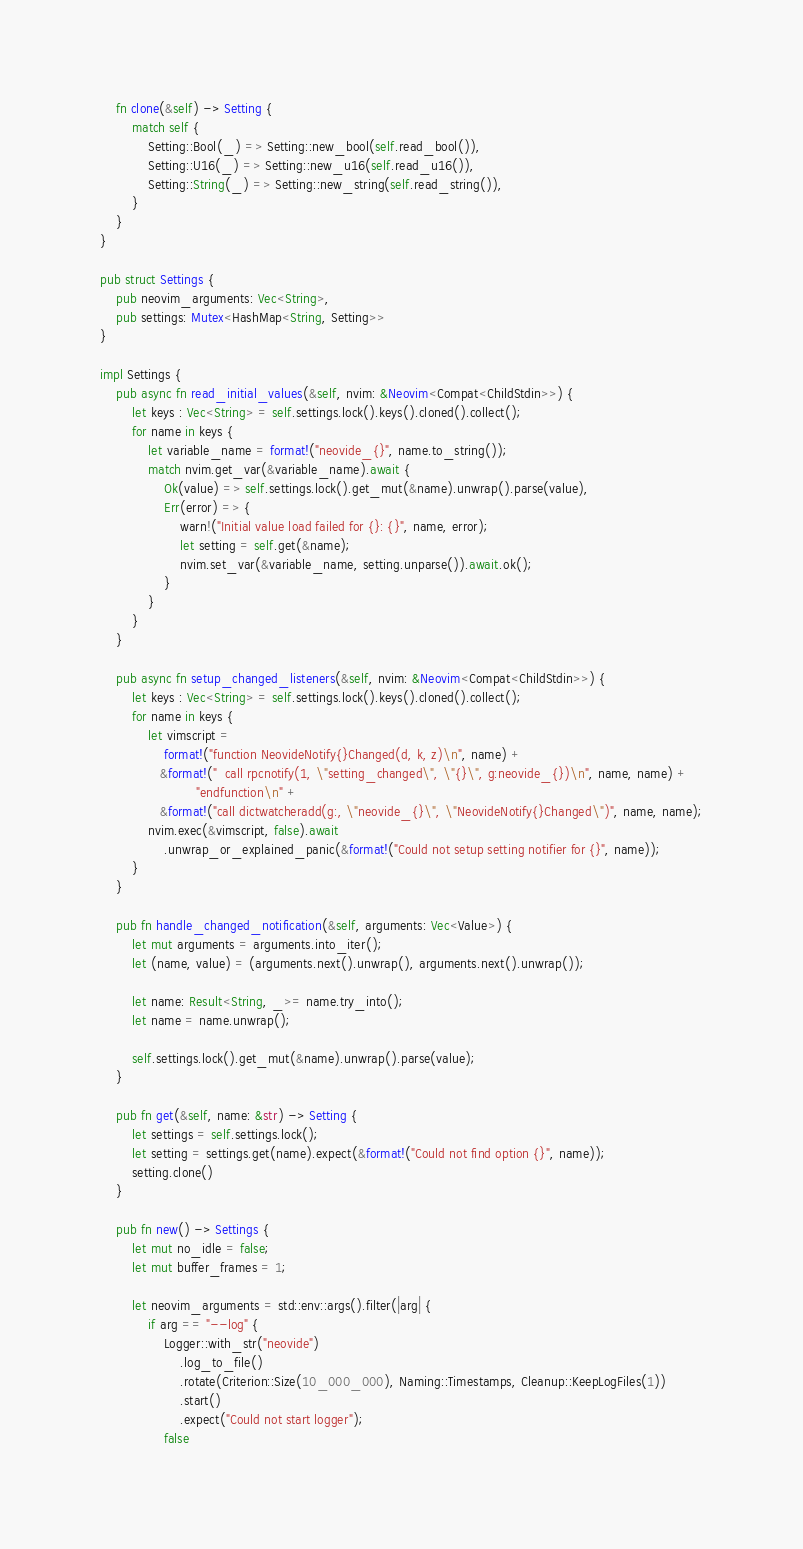<code> <loc_0><loc_0><loc_500><loc_500><_Rust_>
    fn clone(&self) -> Setting {
        match self {
            Setting::Bool(_) => Setting::new_bool(self.read_bool()),
            Setting::U16(_) => Setting::new_u16(self.read_u16()),
            Setting::String(_) => Setting::new_string(self.read_string()),
        }
    }
}

pub struct Settings {
    pub neovim_arguments: Vec<String>,
    pub settings: Mutex<HashMap<String, Setting>>
}

impl Settings {
    pub async fn read_initial_values(&self, nvim: &Neovim<Compat<ChildStdin>>) {
        let keys : Vec<String> = self.settings.lock().keys().cloned().collect();
        for name in keys {
            let variable_name = format!("neovide_{}", name.to_string());
            match nvim.get_var(&variable_name).await {
                Ok(value) => self.settings.lock().get_mut(&name).unwrap().parse(value),
                Err(error) => {
                    warn!("Initial value load failed for {}: {}", name, error);
                    let setting = self.get(&name);
                    nvim.set_var(&variable_name, setting.unparse()).await.ok();
                }
            }
        }
    }

    pub async fn setup_changed_listeners(&self, nvim: &Neovim<Compat<ChildStdin>>) {
        let keys : Vec<String> = self.settings.lock().keys().cloned().collect();
        for name in keys {
            let vimscript = 
                format!("function NeovideNotify{}Changed(d, k, z)\n", name) +
               &format!("  call rpcnotify(1, \"setting_changed\", \"{}\", g:neovide_{})\n", name, name) +
                        "endfunction\n" +
               &format!("call dictwatcheradd(g:, \"neovide_{}\", \"NeovideNotify{}Changed\")", name, name);
            nvim.exec(&vimscript, false).await
                .unwrap_or_explained_panic(&format!("Could not setup setting notifier for {}", name));
        }
    }

    pub fn handle_changed_notification(&self, arguments: Vec<Value>) {
        let mut arguments = arguments.into_iter();
        let (name, value) = (arguments.next().unwrap(), arguments.next().unwrap());
           
        let name: Result<String, _>= name.try_into();
        let name = name.unwrap();

        self.settings.lock().get_mut(&name).unwrap().parse(value);
    }

    pub fn get(&self, name: &str) -> Setting {
        let settings = self.settings.lock();
        let setting = settings.get(name).expect(&format!("Could not find option {}", name));
        setting.clone()
    }

    pub fn new() -> Settings {
        let mut no_idle = false;
        let mut buffer_frames = 1;

        let neovim_arguments = std::env::args().filter(|arg| {
            if arg == "--log" {
                Logger::with_str("neovide")
                    .log_to_file()
                    .rotate(Criterion::Size(10_000_000), Naming::Timestamps, Cleanup::KeepLogFiles(1))
                    .start()
                    .expect("Could not start logger");
                false</code> 